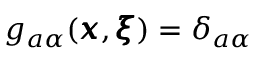<formula> <loc_0><loc_0><loc_500><loc_500>g _ { a \alpha } ( { \pm b x } , { \pm b \xi } ) = \delta _ { a \alpha }</formula> 